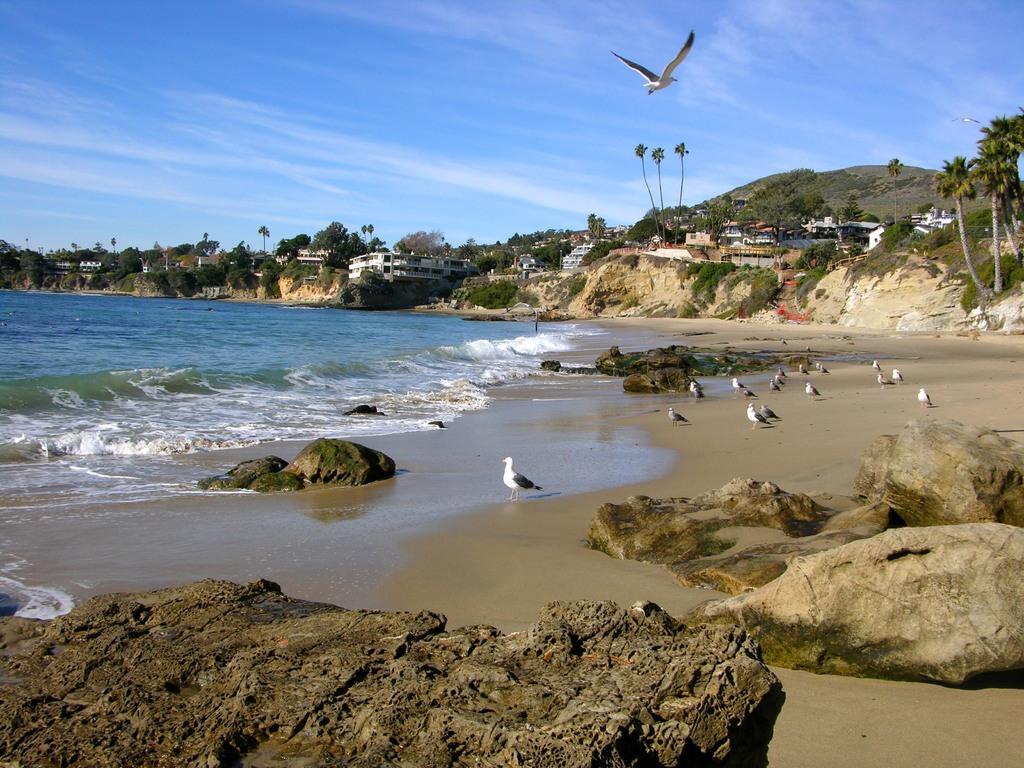In one or two sentences, can you explain what this image depicts? This looks like a seashore. I can see the rocks. These are the birds standing. Here is the sea. I can see the trees and buildings. This is a bird flying in the sky. I think this is a hill. 